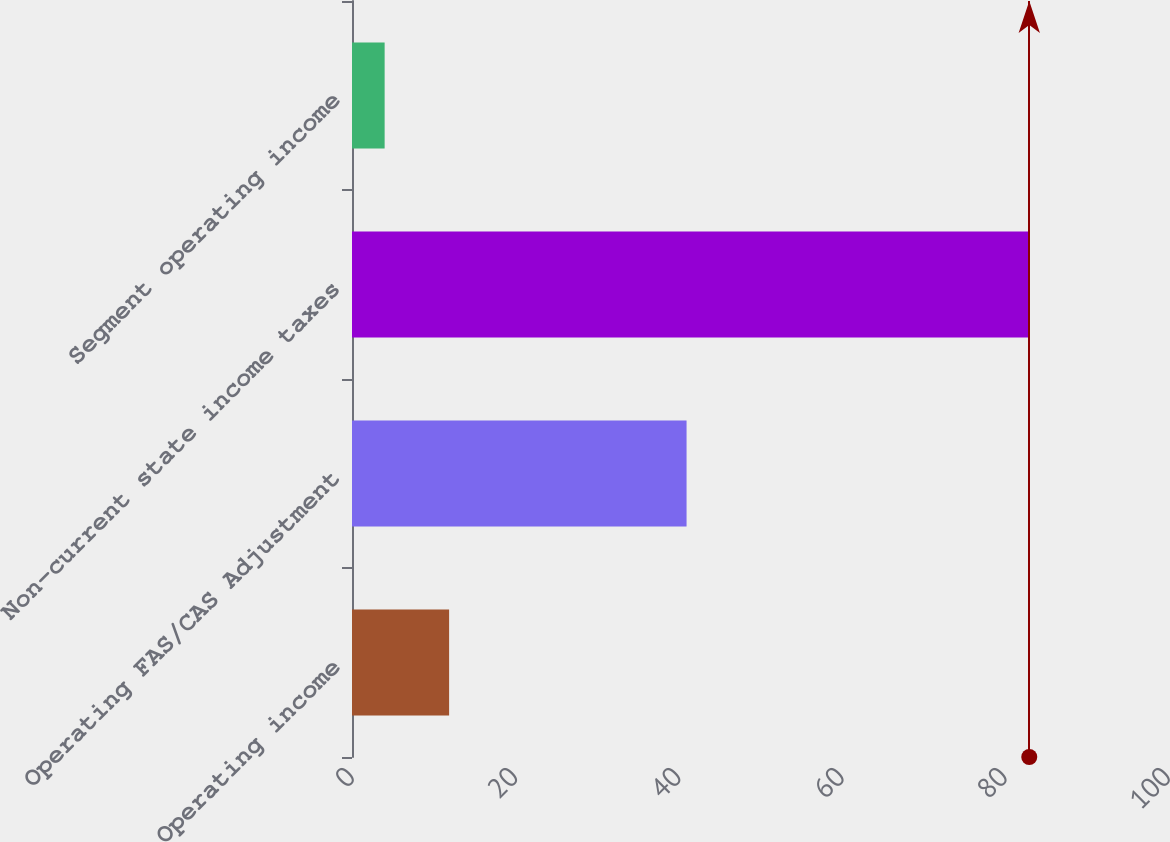Convert chart to OTSL. <chart><loc_0><loc_0><loc_500><loc_500><bar_chart><fcel>Operating income<fcel>Operating FAS/CAS Adjustment<fcel>Non-current state income taxes<fcel>Segment operating income<nl><fcel>11.9<fcel>41<fcel>83<fcel>4<nl></chart> 